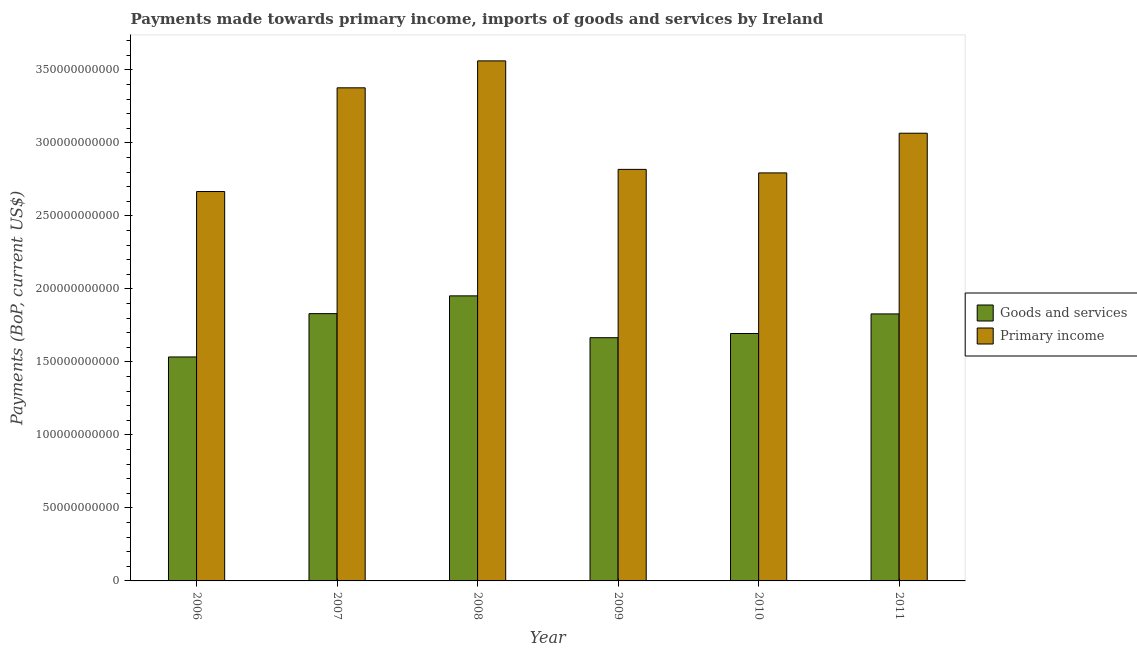How many different coloured bars are there?
Offer a very short reply. 2. Are the number of bars on each tick of the X-axis equal?
Offer a very short reply. Yes. How many bars are there on the 2nd tick from the left?
Provide a succinct answer. 2. How many bars are there on the 6th tick from the right?
Ensure brevity in your answer.  2. What is the payments made towards primary income in 2011?
Give a very brief answer. 3.07e+11. Across all years, what is the maximum payments made towards goods and services?
Offer a terse response. 1.95e+11. Across all years, what is the minimum payments made towards goods and services?
Offer a terse response. 1.53e+11. What is the total payments made towards primary income in the graph?
Ensure brevity in your answer.  1.83e+12. What is the difference between the payments made towards goods and services in 2007 and that in 2011?
Offer a terse response. 1.97e+08. What is the difference between the payments made towards goods and services in 2008 and the payments made towards primary income in 2006?
Offer a very short reply. 4.18e+1. What is the average payments made towards goods and services per year?
Give a very brief answer. 1.75e+11. In the year 2007, what is the difference between the payments made towards goods and services and payments made towards primary income?
Keep it short and to the point. 0. What is the ratio of the payments made towards primary income in 2008 to that in 2011?
Your response must be concise. 1.16. Is the difference between the payments made towards primary income in 2007 and 2008 greater than the difference between the payments made towards goods and services in 2007 and 2008?
Offer a very short reply. No. What is the difference between the highest and the second highest payments made towards goods and services?
Your answer should be compact. 1.22e+1. What is the difference between the highest and the lowest payments made towards primary income?
Provide a succinct answer. 8.95e+1. In how many years, is the payments made towards primary income greater than the average payments made towards primary income taken over all years?
Ensure brevity in your answer.  3. What does the 1st bar from the left in 2011 represents?
Your answer should be compact. Goods and services. What does the 2nd bar from the right in 2009 represents?
Give a very brief answer. Goods and services. How many bars are there?
Your answer should be compact. 12. Are all the bars in the graph horizontal?
Make the answer very short. No. Does the graph contain any zero values?
Your answer should be very brief. No. Does the graph contain grids?
Offer a terse response. No. Where does the legend appear in the graph?
Ensure brevity in your answer.  Center right. How many legend labels are there?
Offer a very short reply. 2. How are the legend labels stacked?
Offer a very short reply. Vertical. What is the title of the graph?
Ensure brevity in your answer.  Payments made towards primary income, imports of goods and services by Ireland. Does "Services" appear as one of the legend labels in the graph?
Make the answer very short. No. What is the label or title of the Y-axis?
Your answer should be compact. Payments (BoP, current US$). What is the Payments (BoP, current US$) of Goods and services in 2006?
Your response must be concise. 1.53e+11. What is the Payments (BoP, current US$) in Primary income in 2006?
Provide a succinct answer. 2.67e+11. What is the Payments (BoP, current US$) in Goods and services in 2007?
Provide a succinct answer. 1.83e+11. What is the Payments (BoP, current US$) in Primary income in 2007?
Give a very brief answer. 3.38e+11. What is the Payments (BoP, current US$) in Goods and services in 2008?
Your response must be concise. 1.95e+11. What is the Payments (BoP, current US$) in Primary income in 2008?
Give a very brief answer. 3.56e+11. What is the Payments (BoP, current US$) in Goods and services in 2009?
Provide a succinct answer. 1.67e+11. What is the Payments (BoP, current US$) of Primary income in 2009?
Offer a very short reply. 2.82e+11. What is the Payments (BoP, current US$) of Goods and services in 2010?
Make the answer very short. 1.69e+11. What is the Payments (BoP, current US$) of Primary income in 2010?
Keep it short and to the point. 2.79e+11. What is the Payments (BoP, current US$) in Goods and services in 2011?
Give a very brief answer. 1.83e+11. What is the Payments (BoP, current US$) in Primary income in 2011?
Provide a short and direct response. 3.07e+11. Across all years, what is the maximum Payments (BoP, current US$) in Goods and services?
Provide a succinct answer. 1.95e+11. Across all years, what is the maximum Payments (BoP, current US$) in Primary income?
Provide a short and direct response. 3.56e+11. Across all years, what is the minimum Payments (BoP, current US$) in Goods and services?
Keep it short and to the point. 1.53e+11. Across all years, what is the minimum Payments (BoP, current US$) in Primary income?
Provide a short and direct response. 2.67e+11. What is the total Payments (BoP, current US$) in Goods and services in the graph?
Your response must be concise. 1.05e+12. What is the total Payments (BoP, current US$) of Primary income in the graph?
Your response must be concise. 1.83e+12. What is the difference between the Payments (BoP, current US$) in Goods and services in 2006 and that in 2007?
Give a very brief answer. -2.97e+1. What is the difference between the Payments (BoP, current US$) of Primary income in 2006 and that in 2007?
Ensure brevity in your answer.  -7.10e+1. What is the difference between the Payments (BoP, current US$) of Goods and services in 2006 and that in 2008?
Ensure brevity in your answer.  -4.18e+1. What is the difference between the Payments (BoP, current US$) in Primary income in 2006 and that in 2008?
Offer a very short reply. -8.95e+1. What is the difference between the Payments (BoP, current US$) in Goods and services in 2006 and that in 2009?
Give a very brief answer. -1.32e+1. What is the difference between the Payments (BoP, current US$) in Primary income in 2006 and that in 2009?
Keep it short and to the point. -1.52e+1. What is the difference between the Payments (BoP, current US$) in Goods and services in 2006 and that in 2010?
Offer a terse response. -1.61e+1. What is the difference between the Payments (BoP, current US$) in Primary income in 2006 and that in 2010?
Offer a very short reply. -1.28e+1. What is the difference between the Payments (BoP, current US$) in Goods and services in 2006 and that in 2011?
Your answer should be compact. -2.95e+1. What is the difference between the Payments (BoP, current US$) in Primary income in 2006 and that in 2011?
Your answer should be compact. -3.99e+1. What is the difference between the Payments (BoP, current US$) of Goods and services in 2007 and that in 2008?
Make the answer very short. -1.22e+1. What is the difference between the Payments (BoP, current US$) in Primary income in 2007 and that in 2008?
Give a very brief answer. -1.85e+1. What is the difference between the Payments (BoP, current US$) in Goods and services in 2007 and that in 2009?
Ensure brevity in your answer.  1.65e+1. What is the difference between the Payments (BoP, current US$) of Primary income in 2007 and that in 2009?
Offer a terse response. 5.58e+1. What is the difference between the Payments (BoP, current US$) of Goods and services in 2007 and that in 2010?
Make the answer very short. 1.36e+1. What is the difference between the Payments (BoP, current US$) in Primary income in 2007 and that in 2010?
Ensure brevity in your answer.  5.83e+1. What is the difference between the Payments (BoP, current US$) in Goods and services in 2007 and that in 2011?
Provide a short and direct response. 1.97e+08. What is the difference between the Payments (BoP, current US$) in Primary income in 2007 and that in 2011?
Provide a short and direct response. 3.11e+1. What is the difference between the Payments (BoP, current US$) of Goods and services in 2008 and that in 2009?
Give a very brief answer. 2.86e+1. What is the difference between the Payments (BoP, current US$) in Primary income in 2008 and that in 2009?
Offer a terse response. 7.43e+1. What is the difference between the Payments (BoP, current US$) in Goods and services in 2008 and that in 2010?
Ensure brevity in your answer.  2.58e+1. What is the difference between the Payments (BoP, current US$) in Primary income in 2008 and that in 2010?
Ensure brevity in your answer.  7.67e+1. What is the difference between the Payments (BoP, current US$) in Goods and services in 2008 and that in 2011?
Your answer should be compact. 1.24e+1. What is the difference between the Payments (BoP, current US$) in Primary income in 2008 and that in 2011?
Your answer should be compact. 4.95e+1. What is the difference between the Payments (BoP, current US$) of Goods and services in 2009 and that in 2010?
Your response must be concise. -2.87e+09. What is the difference between the Payments (BoP, current US$) of Primary income in 2009 and that in 2010?
Your answer should be compact. 2.41e+09. What is the difference between the Payments (BoP, current US$) of Goods and services in 2009 and that in 2011?
Provide a succinct answer. -1.63e+1. What is the difference between the Payments (BoP, current US$) in Primary income in 2009 and that in 2011?
Your response must be concise. -2.48e+1. What is the difference between the Payments (BoP, current US$) in Goods and services in 2010 and that in 2011?
Your response must be concise. -1.34e+1. What is the difference between the Payments (BoP, current US$) in Primary income in 2010 and that in 2011?
Your response must be concise. -2.72e+1. What is the difference between the Payments (BoP, current US$) in Goods and services in 2006 and the Payments (BoP, current US$) in Primary income in 2007?
Ensure brevity in your answer.  -1.84e+11. What is the difference between the Payments (BoP, current US$) of Goods and services in 2006 and the Payments (BoP, current US$) of Primary income in 2008?
Provide a short and direct response. -2.03e+11. What is the difference between the Payments (BoP, current US$) of Goods and services in 2006 and the Payments (BoP, current US$) of Primary income in 2009?
Your answer should be compact. -1.28e+11. What is the difference between the Payments (BoP, current US$) of Goods and services in 2006 and the Payments (BoP, current US$) of Primary income in 2010?
Your answer should be compact. -1.26e+11. What is the difference between the Payments (BoP, current US$) of Goods and services in 2006 and the Payments (BoP, current US$) of Primary income in 2011?
Make the answer very short. -1.53e+11. What is the difference between the Payments (BoP, current US$) of Goods and services in 2007 and the Payments (BoP, current US$) of Primary income in 2008?
Provide a succinct answer. -1.73e+11. What is the difference between the Payments (BoP, current US$) in Goods and services in 2007 and the Payments (BoP, current US$) in Primary income in 2009?
Provide a short and direct response. -9.88e+1. What is the difference between the Payments (BoP, current US$) of Goods and services in 2007 and the Payments (BoP, current US$) of Primary income in 2010?
Give a very brief answer. -9.64e+1. What is the difference between the Payments (BoP, current US$) in Goods and services in 2007 and the Payments (BoP, current US$) in Primary income in 2011?
Keep it short and to the point. -1.24e+11. What is the difference between the Payments (BoP, current US$) in Goods and services in 2008 and the Payments (BoP, current US$) in Primary income in 2009?
Give a very brief answer. -8.66e+1. What is the difference between the Payments (BoP, current US$) of Goods and services in 2008 and the Payments (BoP, current US$) of Primary income in 2010?
Provide a short and direct response. -8.42e+1. What is the difference between the Payments (BoP, current US$) of Goods and services in 2008 and the Payments (BoP, current US$) of Primary income in 2011?
Provide a succinct answer. -1.11e+11. What is the difference between the Payments (BoP, current US$) in Goods and services in 2009 and the Payments (BoP, current US$) in Primary income in 2010?
Make the answer very short. -1.13e+11. What is the difference between the Payments (BoP, current US$) of Goods and services in 2009 and the Payments (BoP, current US$) of Primary income in 2011?
Provide a succinct answer. -1.40e+11. What is the difference between the Payments (BoP, current US$) of Goods and services in 2010 and the Payments (BoP, current US$) of Primary income in 2011?
Provide a short and direct response. -1.37e+11. What is the average Payments (BoP, current US$) of Goods and services per year?
Provide a succinct answer. 1.75e+11. What is the average Payments (BoP, current US$) of Primary income per year?
Your answer should be compact. 3.05e+11. In the year 2006, what is the difference between the Payments (BoP, current US$) of Goods and services and Payments (BoP, current US$) of Primary income?
Offer a terse response. -1.13e+11. In the year 2007, what is the difference between the Payments (BoP, current US$) in Goods and services and Payments (BoP, current US$) in Primary income?
Ensure brevity in your answer.  -1.55e+11. In the year 2008, what is the difference between the Payments (BoP, current US$) of Goods and services and Payments (BoP, current US$) of Primary income?
Your answer should be very brief. -1.61e+11. In the year 2009, what is the difference between the Payments (BoP, current US$) of Goods and services and Payments (BoP, current US$) of Primary income?
Your answer should be very brief. -1.15e+11. In the year 2010, what is the difference between the Payments (BoP, current US$) of Goods and services and Payments (BoP, current US$) of Primary income?
Provide a short and direct response. -1.10e+11. In the year 2011, what is the difference between the Payments (BoP, current US$) of Goods and services and Payments (BoP, current US$) of Primary income?
Ensure brevity in your answer.  -1.24e+11. What is the ratio of the Payments (BoP, current US$) in Goods and services in 2006 to that in 2007?
Your answer should be very brief. 0.84. What is the ratio of the Payments (BoP, current US$) of Primary income in 2006 to that in 2007?
Provide a short and direct response. 0.79. What is the ratio of the Payments (BoP, current US$) in Goods and services in 2006 to that in 2008?
Offer a very short reply. 0.79. What is the ratio of the Payments (BoP, current US$) in Primary income in 2006 to that in 2008?
Your answer should be compact. 0.75. What is the ratio of the Payments (BoP, current US$) in Goods and services in 2006 to that in 2009?
Provide a succinct answer. 0.92. What is the ratio of the Payments (BoP, current US$) in Primary income in 2006 to that in 2009?
Offer a very short reply. 0.95. What is the ratio of the Payments (BoP, current US$) of Goods and services in 2006 to that in 2010?
Provide a succinct answer. 0.91. What is the ratio of the Payments (BoP, current US$) in Primary income in 2006 to that in 2010?
Give a very brief answer. 0.95. What is the ratio of the Payments (BoP, current US$) in Goods and services in 2006 to that in 2011?
Make the answer very short. 0.84. What is the ratio of the Payments (BoP, current US$) in Primary income in 2006 to that in 2011?
Give a very brief answer. 0.87. What is the ratio of the Payments (BoP, current US$) in Goods and services in 2007 to that in 2008?
Your answer should be compact. 0.94. What is the ratio of the Payments (BoP, current US$) of Primary income in 2007 to that in 2008?
Keep it short and to the point. 0.95. What is the ratio of the Payments (BoP, current US$) in Goods and services in 2007 to that in 2009?
Offer a terse response. 1.1. What is the ratio of the Payments (BoP, current US$) in Primary income in 2007 to that in 2009?
Provide a succinct answer. 1.2. What is the ratio of the Payments (BoP, current US$) in Goods and services in 2007 to that in 2010?
Ensure brevity in your answer.  1.08. What is the ratio of the Payments (BoP, current US$) in Primary income in 2007 to that in 2010?
Make the answer very short. 1.21. What is the ratio of the Payments (BoP, current US$) of Goods and services in 2007 to that in 2011?
Offer a very short reply. 1. What is the ratio of the Payments (BoP, current US$) in Primary income in 2007 to that in 2011?
Give a very brief answer. 1.1. What is the ratio of the Payments (BoP, current US$) of Goods and services in 2008 to that in 2009?
Ensure brevity in your answer.  1.17. What is the ratio of the Payments (BoP, current US$) in Primary income in 2008 to that in 2009?
Ensure brevity in your answer.  1.26. What is the ratio of the Payments (BoP, current US$) of Goods and services in 2008 to that in 2010?
Your answer should be compact. 1.15. What is the ratio of the Payments (BoP, current US$) in Primary income in 2008 to that in 2010?
Provide a succinct answer. 1.27. What is the ratio of the Payments (BoP, current US$) in Goods and services in 2008 to that in 2011?
Provide a succinct answer. 1.07. What is the ratio of the Payments (BoP, current US$) of Primary income in 2008 to that in 2011?
Give a very brief answer. 1.16. What is the ratio of the Payments (BoP, current US$) of Goods and services in 2009 to that in 2010?
Make the answer very short. 0.98. What is the ratio of the Payments (BoP, current US$) in Primary income in 2009 to that in 2010?
Give a very brief answer. 1.01. What is the ratio of the Payments (BoP, current US$) in Goods and services in 2009 to that in 2011?
Ensure brevity in your answer.  0.91. What is the ratio of the Payments (BoP, current US$) in Primary income in 2009 to that in 2011?
Offer a very short reply. 0.92. What is the ratio of the Payments (BoP, current US$) of Goods and services in 2010 to that in 2011?
Offer a terse response. 0.93. What is the ratio of the Payments (BoP, current US$) in Primary income in 2010 to that in 2011?
Your response must be concise. 0.91. What is the difference between the highest and the second highest Payments (BoP, current US$) of Goods and services?
Provide a succinct answer. 1.22e+1. What is the difference between the highest and the second highest Payments (BoP, current US$) of Primary income?
Your response must be concise. 1.85e+1. What is the difference between the highest and the lowest Payments (BoP, current US$) in Goods and services?
Your answer should be very brief. 4.18e+1. What is the difference between the highest and the lowest Payments (BoP, current US$) in Primary income?
Offer a very short reply. 8.95e+1. 